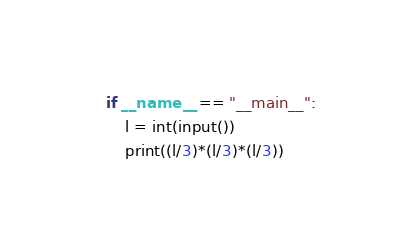<code> <loc_0><loc_0><loc_500><loc_500><_Python_>if __name__ == "__main__":
    l = int(input())
    print((l/3)*(l/3)*(l/3))
</code> 